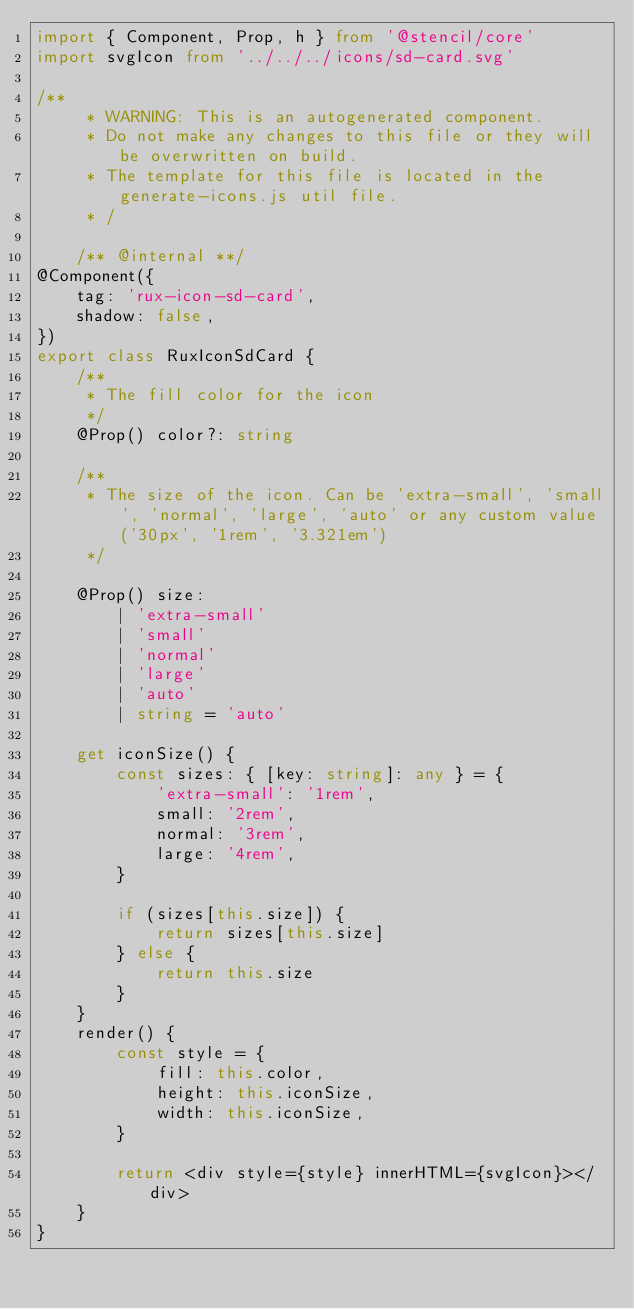<code> <loc_0><loc_0><loc_500><loc_500><_TypeScript_>import { Component, Prop, h } from '@stencil/core'
import svgIcon from '../../../icons/sd-card.svg'

/**
     * WARNING: This is an autogenerated component.
     * Do not make any changes to this file or they will be overwritten on build.
     * The template for this file is located in the generate-icons.js util file.
     * /

    /** @internal **/
@Component({
    tag: 'rux-icon-sd-card',
    shadow: false,
})
export class RuxIconSdCard {
    /**
     * The fill color for the icon
     */
    @Prop() color?: string

    /**
     * The size of the icon. Can be 'extra-small', 'small', 'normal', 'large', 'auto' or any custom value ('30px', '1rem', '3.321em')
     */

    @Prop() size:
        | 'extra-small'
        | 'small'
        | 'normal'
        | 'large'
        | 'auto'
        | string = 'auto'

    get iconSize() {
        const sizes: { [key: string]: any } = {
            'extra-small': '1rem',
            small: '2rem',
            normal: '3rem',
            large: '4rem',
        }

        if (sizes[this.size]) {
            return sizes[this.size]
        } else {
            return this.size
        }
    }
    render() {
        const style = {
            fill: this.color,
            height: this.iconSize,
            width: this.iconSize,
        }

        return <div style={style} innerHTML={svgIcon}></div>
    }
}
</code> 